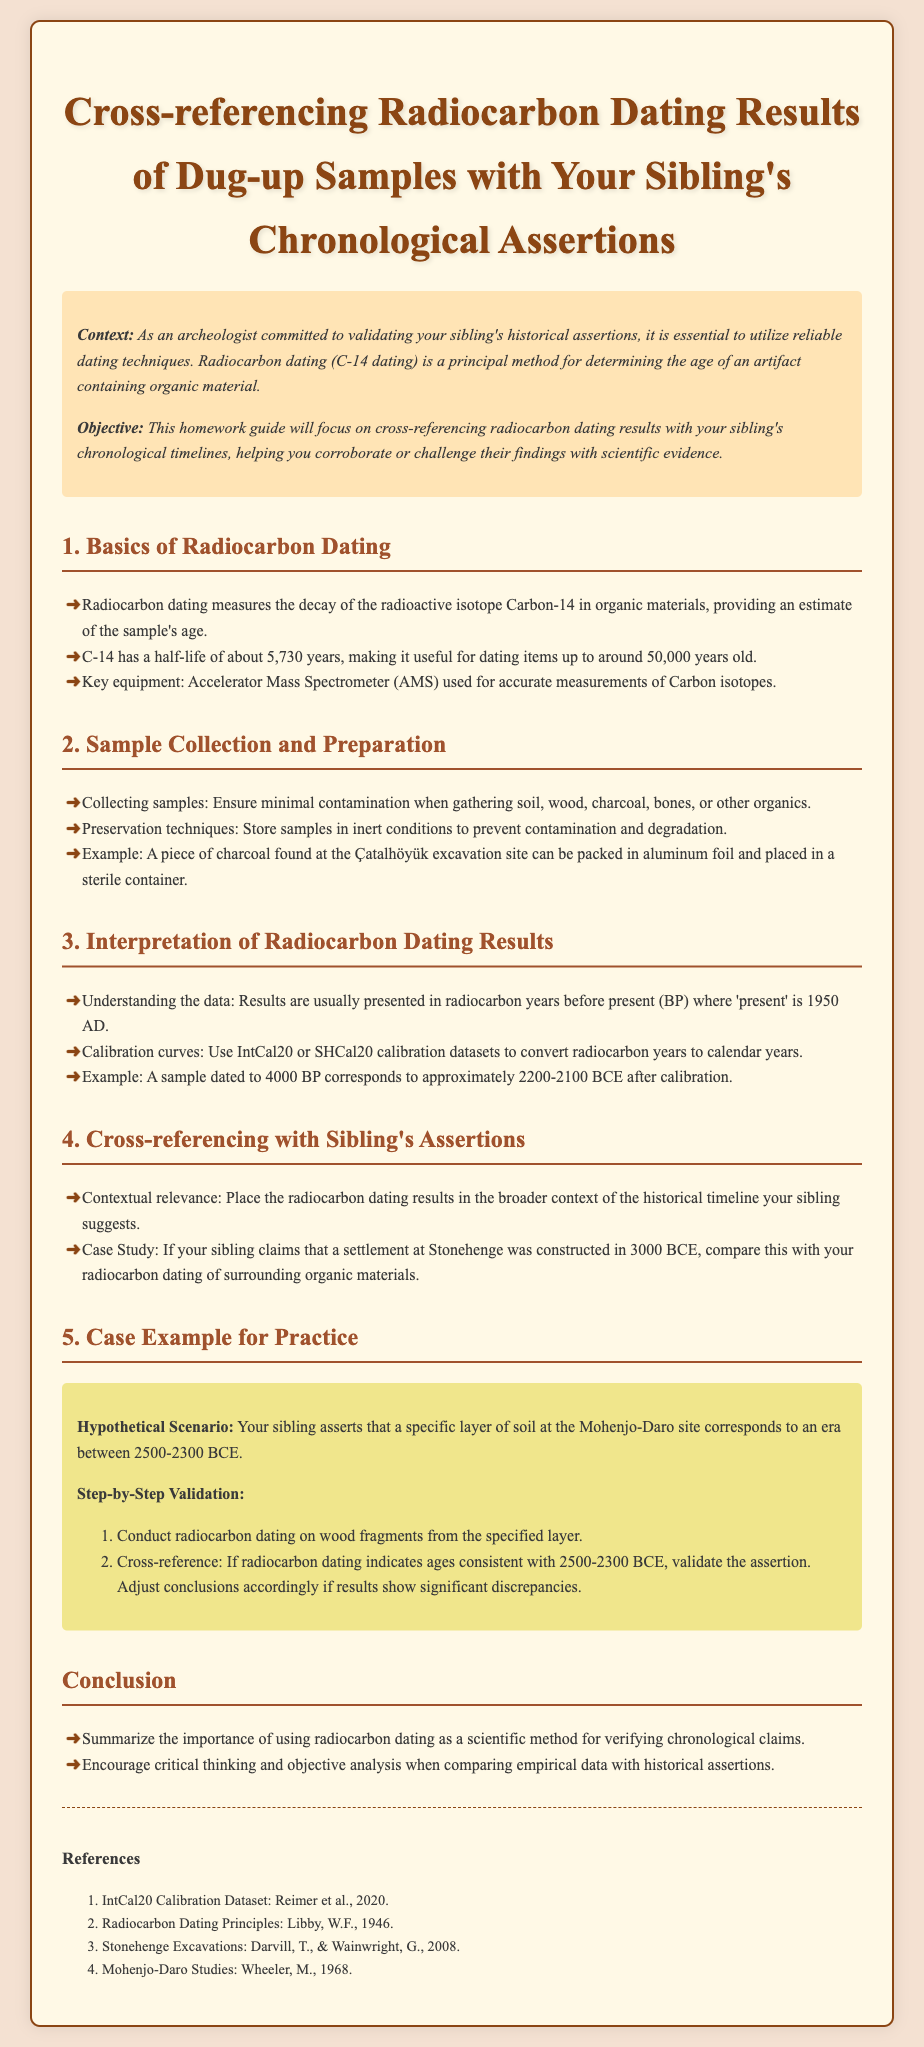what is the half-life of C-14? The document states that the half-life of C-14 is about 5,730 years.
Answer: 5,730 years what is one example of a material that can be dated? The document lists wood, charcoal, and bones as examples of materials that can be dated using radiocarbon dating.
Answer: wood what calibration curves are mentioned for radiocarbon dating? The document refers to IntCal20 and SHCal20 as calibration curves for converting radiocarbon years to calendar years.
Answer: IntCal20 or SHCal20 what is the primary method for determining the age of organic artifacts? The document highlights radiocarbon dating (C-14 dating) as the principal method for determining age.
Answer: radiocarbon dating which excavation site is used as an example in the preservation techniques section? The document mentions the Çatalhöyük excavation site as an example.
Answer: Çatalhöyük what era does the hypothetical scenario in the case example suggest? The document indicates that the sibling's assertion corresponds to an era between 2500-2300 BCE.
Answer: 2500-2300 BCE how should samples be stored to prevent contamination? The document states that samples should be stored in inert conditions to prevent contamination and degradation.
Answer: inert conditions who are the authors mentioned in the references regarding radiocarbon dating principles? The document notes W.F. Libby as the author of the principles of radiocarbon dating.
Answer: W.F. Libby 